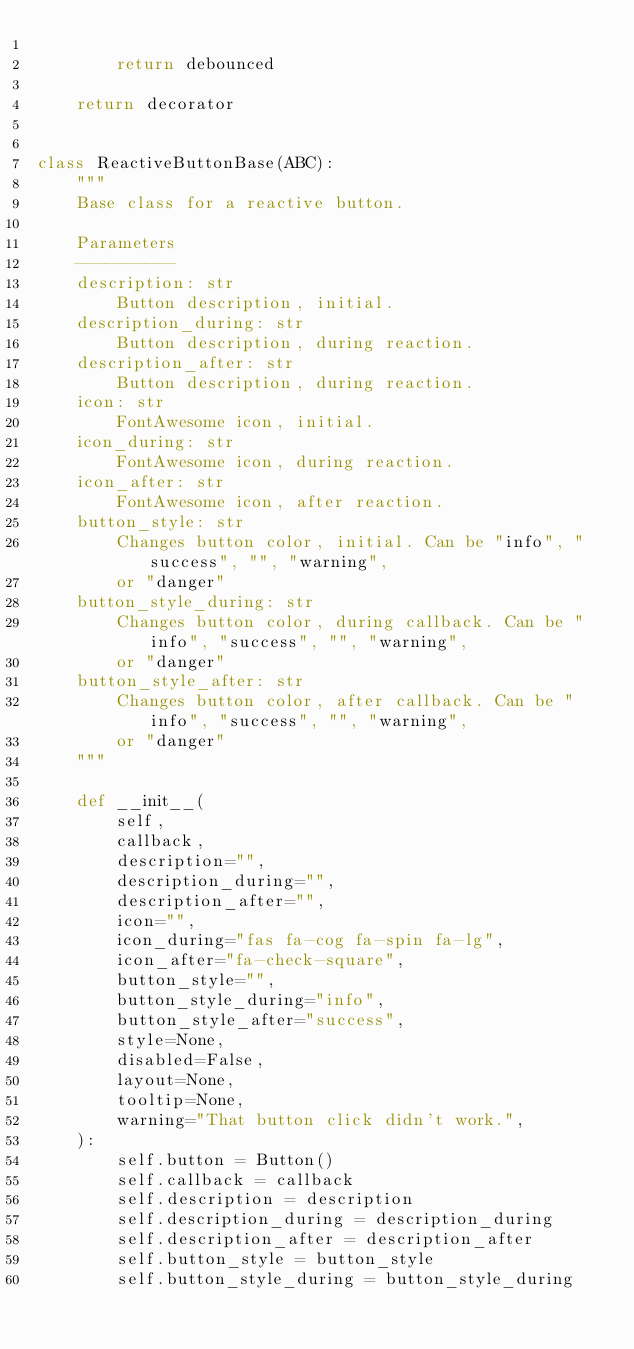Convert code to text. <code><loc_0><loc_0><loc_500><loc_500><_Python_>
        return debounced

    return decorator


class ReactiveButtonBase(ABC):
    """
    Base class for a reactive button.

    Parameters
    ----------
    description: str
        Button description, initial.
    description_during: str
        Button description, during reaction.
    description_after: str
        Button description, during reaction.
    icon: str
        FontAwesome icon, initial.
    icon_during: str
        FontAwesome icon, during reaction.
    icon_after: str
        FontAwesome icon, after reaction.
    button_style: str
        Changes button color, initial. Can be "info", "success", "", "warning",
        or "danger"
    button_style_during: str
        Changes button color, during callback. Can be "info", "success", "", "warning",
        or "danger"
    button_style_after: str
        Changes button color, after callback. Can be "info", "success", "", "warning",
        or "danger"
    """

    def __init__(
        self,
        callback,
        description="",
        description_during="",
        description_after="",
        icon="",
        icon_during="fas fa-cog fa-spin fa-lg",
        icon_after="fa-check-square",
        button_style="",
        button_style_during="info",
        button_style_after="success",
        style=None,
        disabled=False,
        layout=None,
        tooltip=None,
        warning="That button click didn't work.",
    ):
        self.button = Button()
        self.callback = callback
        self.description = description
        self.description_during = description_during
        self.description_after = description_after
        self.button_style = button_style
        self.button_style_during = button_style_during</code> 